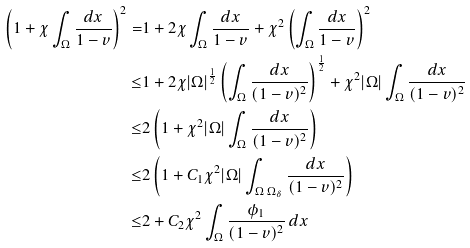Convert formula to latex. <formula><loc_0><loc_0><loc_500><loc_500>\left ( 1 + \chi \int _ { \Omega } \frac { d x } { 1 - v } \right ) ^ { 2 } = & 1 + 2 \chi \int _ { \Omega } \frac { d x } { 1 - v } + \chi ^ { 2 } \left ( \int _ { \Omega } \frac { d x } { 1 - v } \right ) ^ { 2 } \\ \leq & 1 + 2 \chi | \Omega | ^ { \frac { 1 } { 2 } } \left ( \int _ { \Omega } \frac { d x } { ( 1 - v ) ^ { 2 } } \right ) ^ { \frac { 1 } { 2 } } + \chi ^ { 2 } | \Omega | \int _ { \Omega } \frac { d x } { ( 1 - v ) ^ { 2 } } \\ \leq & 2 \left ( 1 + \chi ^ { 2 } | \Omega | \int _ { \Omega } \frac { d x } { ( 1 - v ) ^ { 2 } } \right ) \\ \leq & 2 \left ( 1 + C _ { 1 } \chi ^ { 2 } | \Omega | \int _ { \Omega \ \Omega _ { \delta } } \frac { d x } { ( 1 - v ) ^ { 2 } } \right ) \\ \leq & 2 + C _ { 2 } \chi ^ { 2 } \int _ { \Omega } \frac { \phi _ { 1 } } { ( 1 - v ) ^ { 2 } } \, d x</formula> 